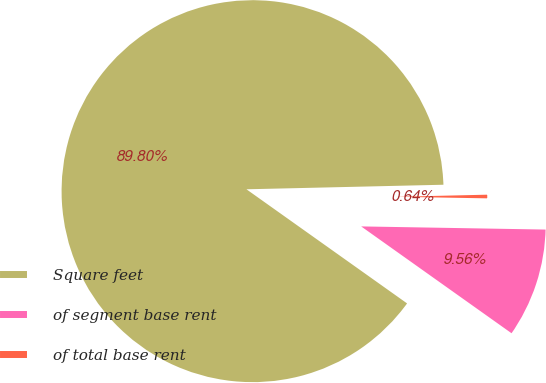Convert chart to OTSL. <chart><loc_0><loc_0><loc_500><loc_500><pie_chart><fcel>Square feet<fcel>of segment base rent<fcel>of total base rent<nl><fcel>89.8%<fcel>9.56%<fcel>0.64%<nl></chart> 